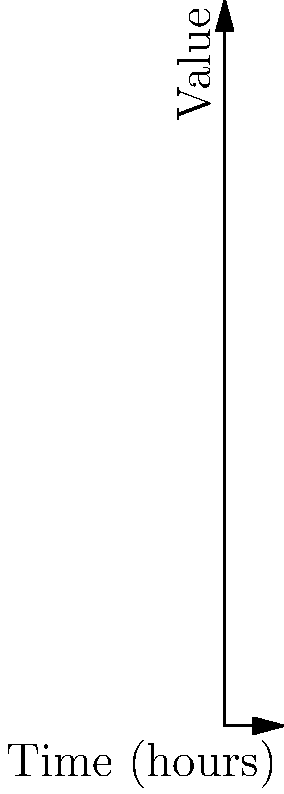Analyze the wearable health device data chart showing heart rate, blood pressure, and blood sugar levels over a 12-hour period. At which hour does the data suggest the monitored individual might have engaged in physical activity or experienced stress? To determine when the individual might have engaged in physical activity or experienced stress, we need to look for significant increases in the measured health parameters:

1. Examine the heart rate (blue line):
   - It starts around 70 bpm and increases steadily.
   - The peak occurs at hour 5, reaching about 90 bpm.

2. Look at the blood pressure (red line):
   - It follows a similar pattern to heart rate.
   - The peak also occurs at hour 5, reaching about 140 mmHg.

3. Check the blood sugar levels (green line):
   - It shows a similar trend, peaking at hour 5.

4. Analyze the overall pattern:
   - All three parameters show a consistent increase from hour 0 to hour 5.
   - After hour 5, all parameters begin to decrease gradually.

5. Interpret the data:
   - The simultaneous increase in heart rate, blood pressure, and blood sugar typically indicates physical activity or stress.
   - The peak at hour 5 suggests this is when the activity or stress was most intense.

Therefore, based on the data, the individual likely engaged in physical activity or experienced stress at hour 5.
Answer: Hour 5 